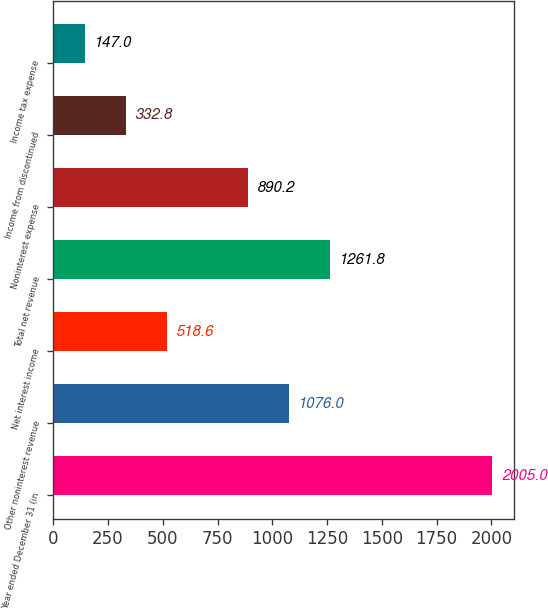Convert chart to OTSL. <chart><loc_0><loc_0><loc_500><loc_500><bar_chart><fcel>Year ended December 31 (in<fcel>Other noninterest revenue<fcel>Net interest income<fcel>Total net revenue<fcel>Noninterest expense<fcel>Income from discontinued<fcel>Income tax expense<nl><fcel>2005<fcel>1076<fcel>518.6<fcel>1261.8<fcel>890.2<fcel>332.8<fcel>147<nl></chart> 